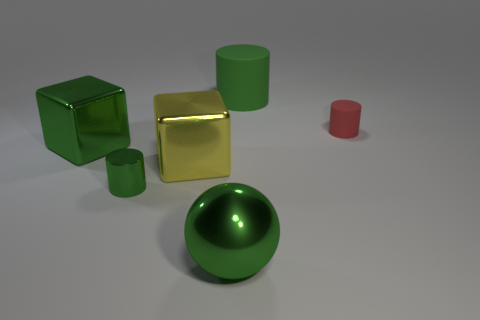There is a cylinder that is left of the green metal ball; is its color the same as the cylinder that is behind the tiny red rubber object?
Your response must be concise. Yes. What number of green metallic blocks are to the left of the small cylinder that is on the left side of the big matte cylinder?
Ensure brevity in your answer.  1. What number of metallic things are red objects or big cyan balls?
Your response must be concise. 0. Is there another green sphere made of the same material as the green sphere?
Your answer should be very brief. No. How many things are either big things that are behind the yellow metallic cube or tiny cylinders that are to the right of the large ball?
Your response must be concise. 3. Is the color of the rubber thing that is behind the red matte object the same as the sphere?
Your answer should be very brief. Yes. What number of other things are there of the same color as the small matte thing?
Your answer should be compact. 0. What material is the sphere?
Give a very brief answer. Metal. Is the size of the shiny thing that is behind the yellow cube the same as the big green sphere?
Your response must be concise. Yes. There is a green thing that is the same shape as the yellow shiny object; what is its size?
Your response must be concise. Large. 